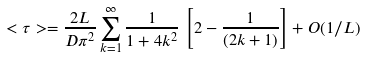<formula> <loc_0><loc_0><loc_500><loc_500>< \tau > = \frac { 2 L } { D \pi ^ { 2 } } \sum _ { k = 1 } ^ { \infty } \frac { 1 } { 1 + 4 k ^ { 2 } } \, \left [ 2 - \frac { 1 } { ( 2 k + 1 ) } \right ] + O ( 1 / L )</formula> 